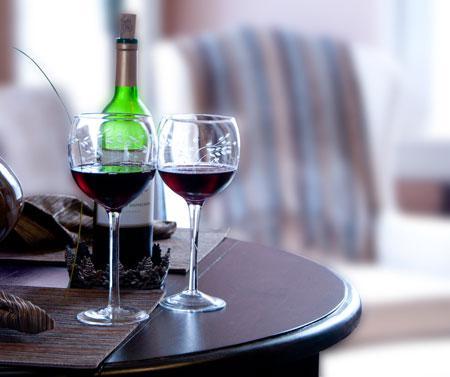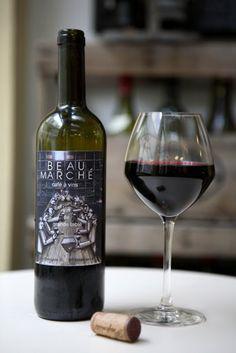The first image is the image on the left, the second image is the image on the right. For the images displayed, is the sentence "There is more than one wine glass in one of the images." factually correct? Answer yes or no. Yes. 